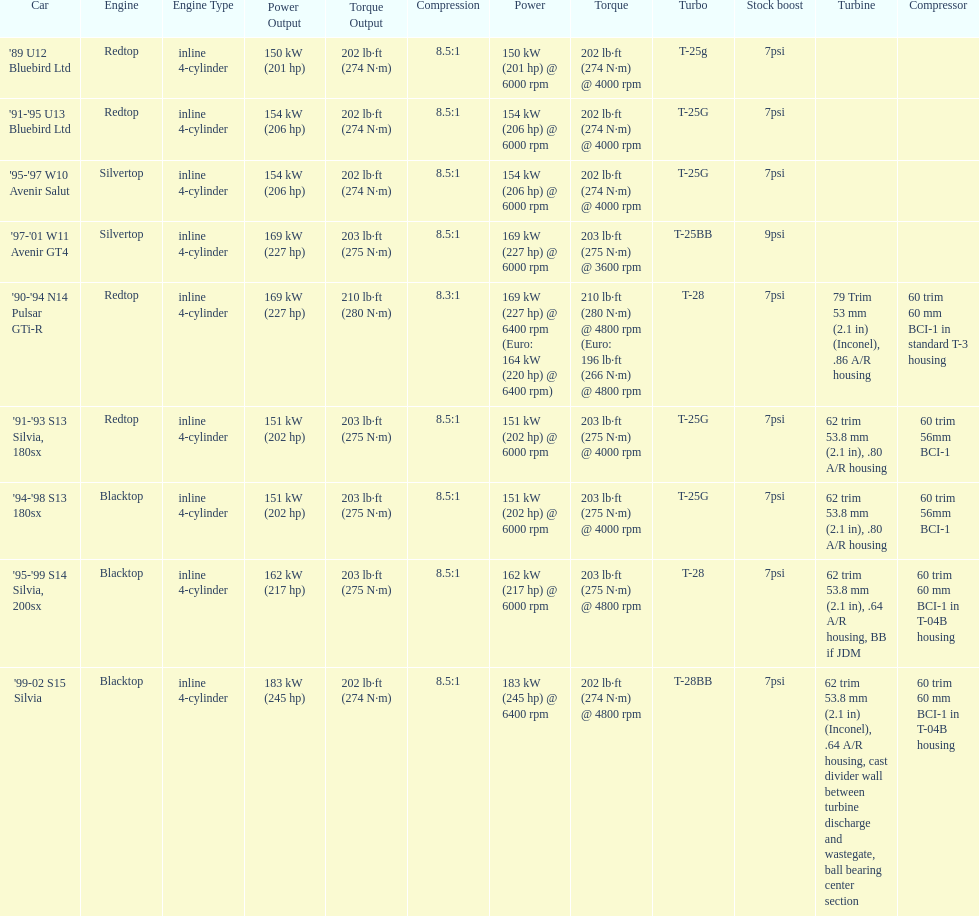Which car has a stock boost of over 7psi? '97-'01 W11 Avenir GT4. 